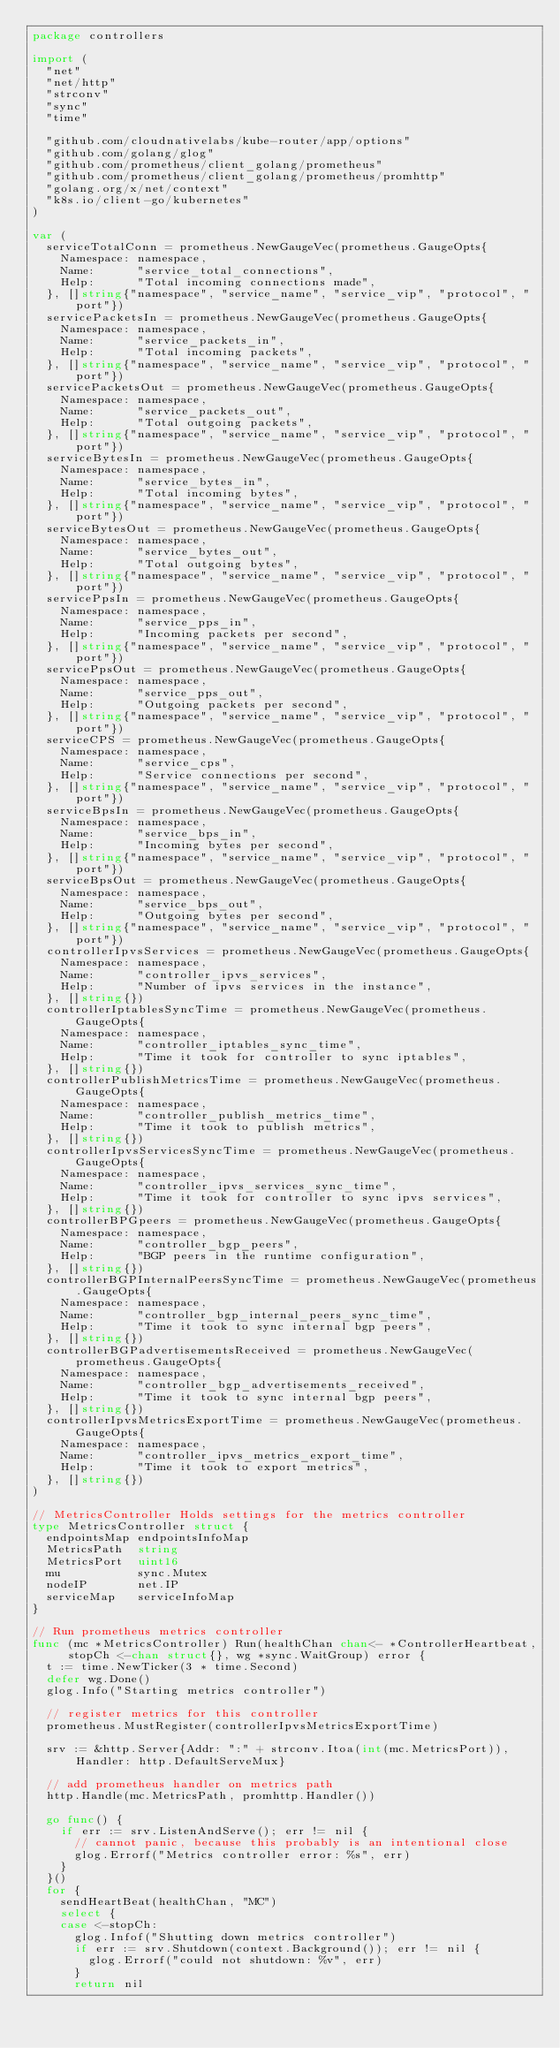Convert code to text. <code><loc_0><loc_0><loc_500><loc_500><_Go_>package controllers

import (
	"net"
	"net/http"
	"strconv"
	"sync"
	"time"

	"github.com/cloudnativelabs/kube-router/app/options"
	"github.com/golang/glog"
	"github.com/prometheus/client_golang/prometheus"
	"github.com/prometheus/client_golang/prometheus/promhttp"
	"golang.org/x/net/context"
	"k8s.io/client-go/kubernetes"
)

var (
	serviceTotalConn = prometheus.NewGaugeVec(prometheus.GaugeOpts{
		Namespace: namespace,
		Name:      "service_total_connections",
		Help:      "Total incoming connections made",
	}, []string{"namespace", "service_name", "service_vip", "protocol", "port"})
	servicePacketsIn = prometheus.NewGaugeVec(prometheus.GaugeOpts{
		Namespace: namespace,
		Name:      "service_packets_in",
		Help:      "Total incoming packets",
	}, []string{"namespace", "service_name", "service_vip", "protocol", "port"})
	servicePacketsOut = prometheus.NewGaugeVec(prometheus.GaugeOpts{
		Namespace: namespace,
		Name:      "service_packets_out",
		Help:      "Total outgoing packets",
	}, []string{"namespace", "service_name", "service_vip", "protocol", "port"})
	serviceBytesIn = prometheus.NewGaugeVec(prometheus.GaugeOpts{
		Namespace: namespace,
		Name:      "service_bytes_in",
		Help:      "Total incoming bytes",
	}, []string{"namespace", "service_name", "service_vip", "protocol", "port"})
	serviceBytesOut = prometheus.NewGaugeVec(prometheus.GaugeOpts{
		Namespace: namespace,
		Name:      "service_bytes_out",
		Help:      "Total outgoing bytes",
	}, []string{"namespace", "service_name", "service_vip", "protocol", "port"})
	servicePpsIn = prometheus.NewGaugeVec(prometheus.GaugeOpts{
		Namespace: namespace,
		Name:      "service_pps_in",
		Help:      "Incoming packets per second",
	}, []string{"namespace", "service_name", "service_vip", "protocol", "port"})
	servicePpsOut = prometheus.NewGaugeVec(prometheus.GaugeOpts{
		Namespace: namespace,
		Name:      "service_pps_out",
		Help:      "Outgoing packets per second",
	}, []string{"namespace", "service_name", "service_vip", "protocol", "port"})
	serviceCPS = prometheus.NewGaugeVec(prometheus.GaugeOpts{
		Namespace: namespace,
		Name:      "service_cps",
		Help:      "Service connections per second",
	}, []string{"namespace", "service_name", "service_vip", "protocol", "port"})
	serviceBpsIn = prometheus.NewGaugeVec(prometheus.GaugeOpts{
		Namespace: namespace,
		Name:      "service_bps_in",
		Help:      "Incoming bytes per second",
	}, []string{"namespace", "service_name", "service_vip", "protocol", "port"})
	serviceBpsOut = prometheus.NewGaugeVec(prometheus.GaugeOpts{
		Namespace: namespace,
		Name:      "service_bps_out",
		Help:      "Outgoing bytes per second",
	}, []string{"namespace", "service_name", "service_vip", "protocol", "port"})
	controllerIpvsServices = prometheus.NewGaugeVec(prometheus.GaugeOpts{
		Namespace: namespace,
		Name:      "controller_ipvs_services",
		Help:      "Number of ipvs services in the instance",
	}, []string{})
	controllerIptablesSyncTime = prometheus.NewGaugeVec(prometheus.GaugeOpts{
		Namespace: namespace,
		Name:      "controller_iptables_sync_time",
		Help:      "Time it took for controller to sync iptables",
	}, []string{})
	controllerPublishMetricsTime = prometheus.NewGaugeVec(prometheus.GaugeOpts{
		Namespace: namespace,
		Name:      "controller_publish_metrics_time",
		Help:      "Time it took to publish metrics",
	}, []string{})
	controllerIpvsServicesSyncTime = prometheus.NewGaugeVec(prometheus.GaugeOpts{
		Namespace: namespace,
		Name:      "controller_ipvs_services_sync_time",
		Help:      "Time it took for controller to sync ipvs services",
	}, []string{})
	controllerBPGpeers = prometheus.NewGaugeVec(prometheus.GaugeOpts{
		Namespace: namespace,
		Name:      "controller_bgp_peers",
		Help:      "BGP peers in the runtime configuration",
	}, []string{})
	controllerBGPInternalPeersSyncTime = prometheus.NewGaugeVec(prometheus.GaugeOpts{
		Namespace: namespace,
		Name:      "controller_bgp_internal_peers_sync_time",
		Help:      "Time it took to sync internal bgp peers",
	}, []string{})
	controllerBGPadvertisementsReceived = prometheus.NewGaugeVec(prometheus.GaugeOpts{
		Namespace: namespace,
		Name:      "controller_bgp_advertisements_received",
		Help:      "Time it took to sync internal bgp peers",
	}, []string{})
	controllerIpvsMetricsExportTime = prometheus.NewGaugeVec(prometheus.GaugeOpts{
		Namespace: namespace,
		Name:      "controller_ipvs_metrics_export_time",
		Help:      "Time it took to export metrics",
	}, []string{})
)

// MetricsController Holds settings for the metrics controller
type MetricsController struct {
	endpointsMap endpointsInfoMap
	MetricsPath  string
	MetricsPort  uint16
	mu           sync.Mutex
	nodeIP       net.IP
	serviceMap   serviceInfoMap
}

// Run prometheus metrics controller
func (mc *MetricsController) Run(healthChan chan<- *ControllerHeartbeat, stopCh <-chan struct{}, wg *sync.WaitGroup) error {
	t := time.NewTicker(3 * time.Second)
	defer wg.Done()
	glog.Info("Starting metrics controller")

	// register metrics for this controller
	prometheus.MustRegister(controllerIpvsMetricsExportTime)

	srv := &http.Server{Addr: ":" + strconv.Itoa(int(mc.MetricsPort)), Handler: http.DefaultServeMux}

	// add prometheus handler on metrics path
	http.Handle(mc.MetricsPath, promhttp.Handler())

	go func() {
		if err := srv.ListenAndServe(); err != nil {
			// cannot panic, because this probably is an intentional close
			glog.Errorf("Metrics controller error: %s", err)
		}
	}()
	for {
		sendHeartBeat(healthChan, "MC")
		select {
		case <-stopCh:
			glog.Infof("Shutting down metrics controller")
			if err := srv.Shutdown(context.Background()); err != nil {
				glog.Errorf("could not shutdown: %v", err)
			}
			return nil</code> 